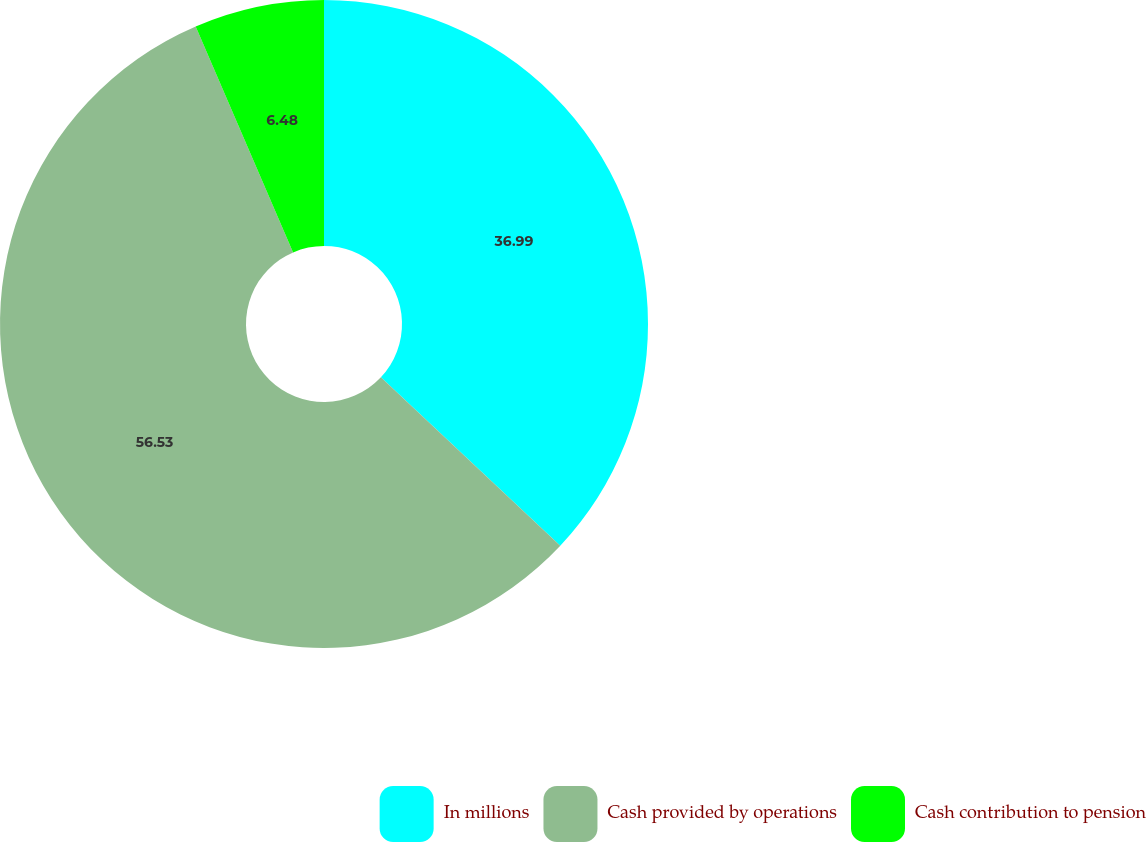<chart> <loc_0><loc_0><loc_500><loc_500><pie_chart><fcel>In millions<fcel>Cash provided by operations<fcel>Cash contribution to pension<nl><fcel>36.99%<fcel>56.52%<fcel>6.48%<nl></chart> 